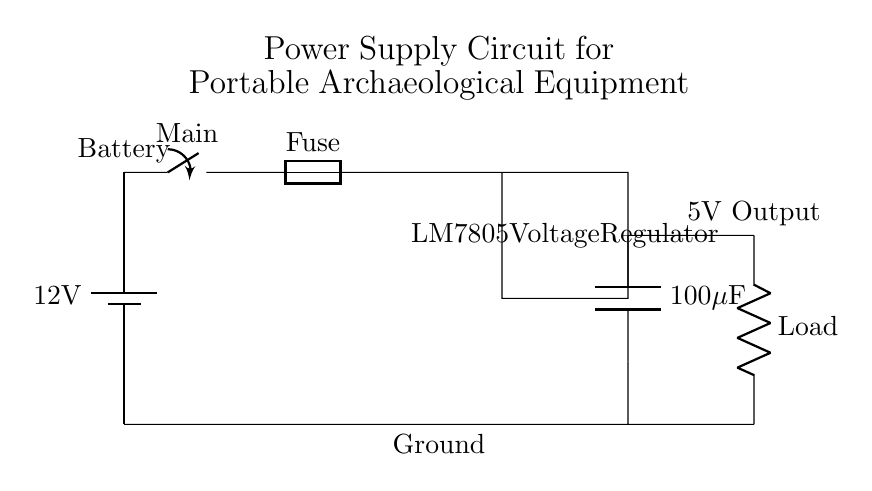What type of battery is used in this circuit? The circuit diagram indicates a single battery that supplies 12 volts. This is shown at the top left corner of the circuit, labeled as a battery.
Answer: 12V battery What is the function of the switch in the circuit? The switch in the circuit allows for the control of power flow; it can disconnect the circuit from the battery when turned off. This is depicted in the connection immediately following the battery.
Answer: Power control What component regulates the voltage output? The voltage regulator, indicated as "LM7805," is responsible for regulating the output voltage to a fixed level of 5 volts, as shown enclosed in a rectangle in the circuit.
Answer: LM7805 What is the output voltage of this circuit? The output voltage, as indicated in the diagram, is a stable 5 volts provided by the LM7805 voltage regulator to the load. This is specifically labeled at the output part of the circuit.
Answer: 5V Why is a capacitor used in this circuit? The output capacitor is used to smooth the output voltage from the LM7805 voltage regulator, reducing voltage fluctuations which can affect the performance of the load. This is represented as a capacitor connected at the output section of the circuit.
Answer: Smoothing What component protects the circuit from overload? The fuse in the circuit serves as a protective device that will blow if too much current flows through it, thus preventing damage to the other components. Its inclusion is illustrated next to the switch.
Answer: Fuse 